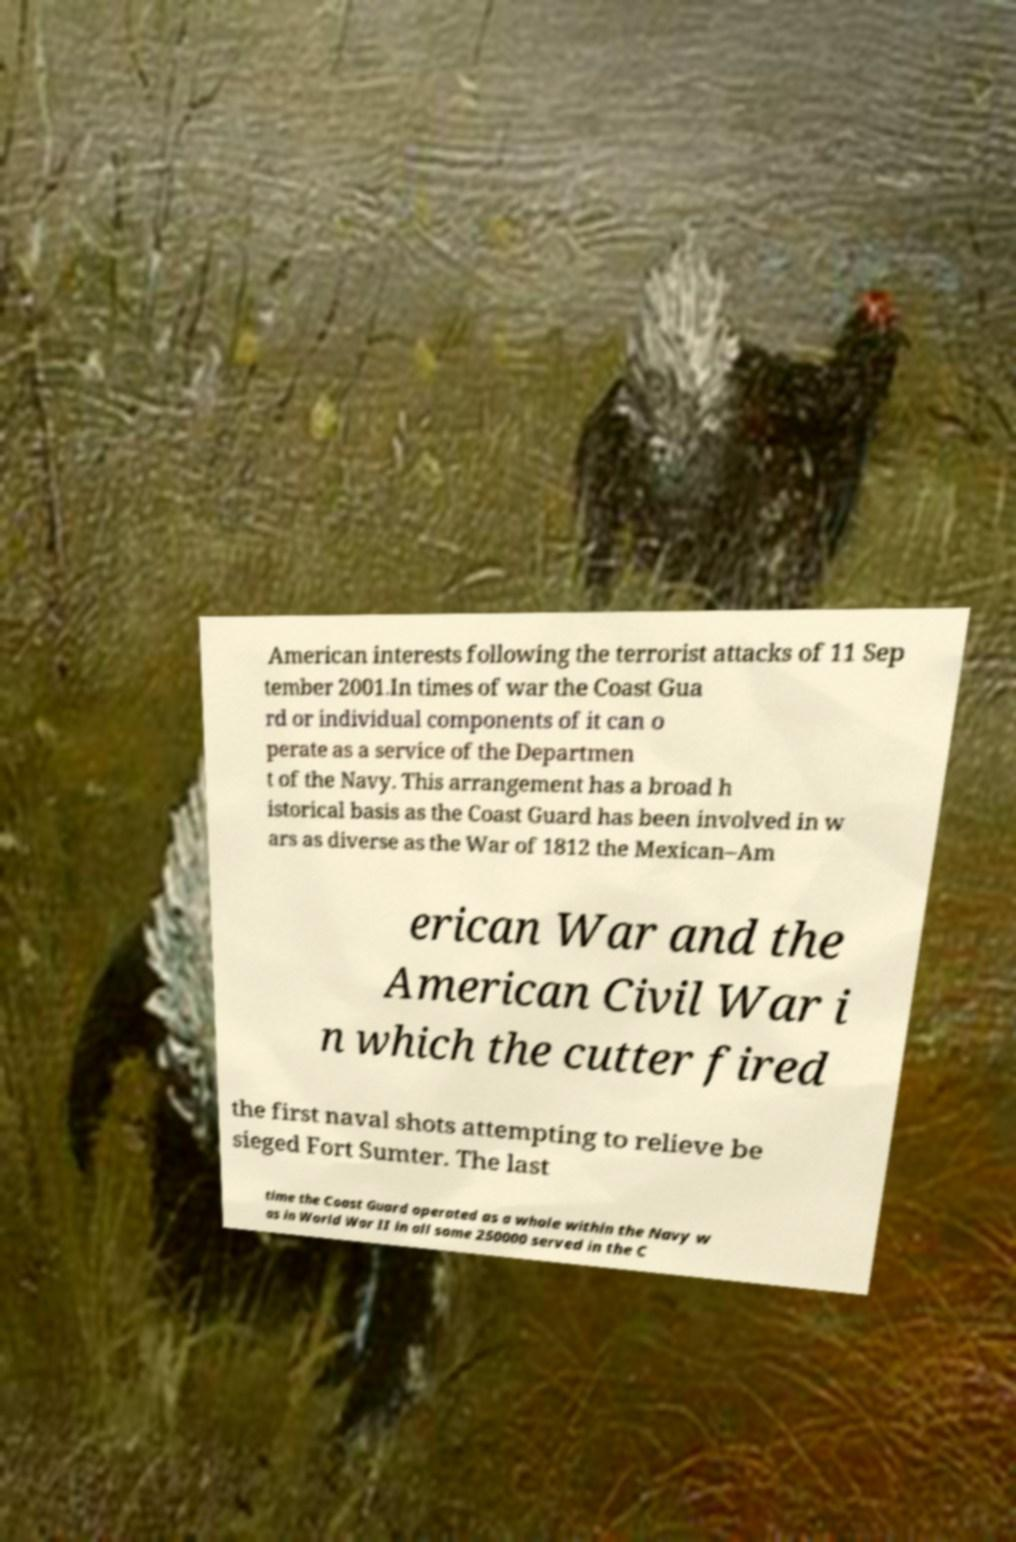There's text embedded in this image that I need extracted. Can you transcribe it verbatim? American interests following the terrorist attacks of 11 Sep tember 2001.In times of war the Coast Gua rd or individual components of it can o perate as a service of the Departmen t of the Navy. This arrangement has a broad h istorical basis as the Coast Guard has been involved in w ars as diverse as the War of 1812 the Mexican–Am erican War and the American Civil War i n which the cutter fired the first naval shots attempting to relieve be sieged Fort Sumter. The last time the Coast Guard operated as a whole within the Navy w as in World War II in all some 250000 served in the C 